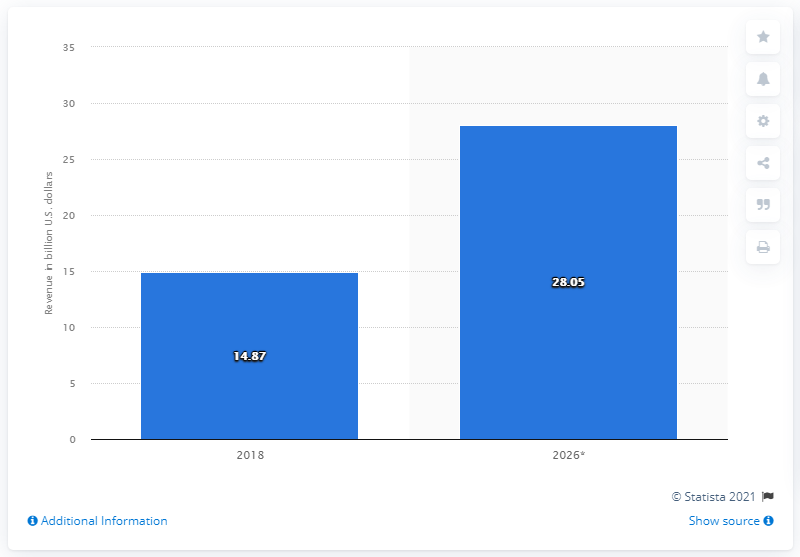Draw attention to some important aspects in this diagram. The forecast market size of ASIC chips is expected to be approximately 28.05 billion U.S. dollars in 2026. 